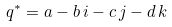<formula> <loc_0><loc_0><loc_500><loc_500>q ^ { * } = a - b \, i - c \, j - d \, k</formula> 